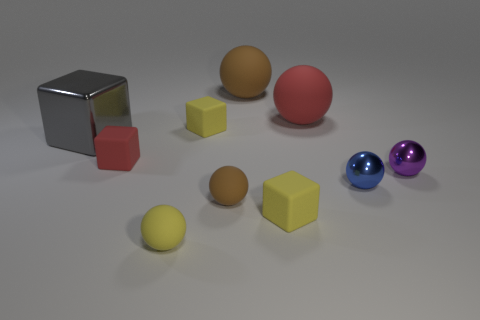There is a red object that is the same shape as the purple thing; what size is it?
Your answer should be compact. Large. There is a small purple metal ball; what number of big gray cubes are in front of it?
Your answer should be compact. 0. What number of green objects are rubber objects or large balls?
Give a very brief answer. 0. The rubber ball behind the red matte thing that is right of the yellow ball is what color?
Provide a short and direct response. Brown. There is a rubber ball behind the red ball; what is its color?
Provide a short and direct response. Brown. Does the brown matte thing that is behind the gray block have the same size as the purple thing?
Your response must be concise. No. Is there a matte cylinder that has the same size as the gray metal cube?
Offer a very short reply. No. There is a block that is in front of the purple ball; is it the same color as the ball in front of the tiny brown ball?
Keep it short and to the point. Yes. Is there a large metal thing of the same color as the shiny block?
Make the answer very short. No. What number of other objects are there of the same shape as the tiny brown rubber thing?
Ensure brevity in your answer.  5. 